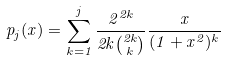<formula> <loc_0><loc_0><loc_500><loc_500>p _ { j } ( x ) = \sum _ { k = 1 } ^ { j } \frac { 2 ^ { 2 k } } { 2 k \binom { 2 k } { k } } \frac { x } { ( 1 + x ^ { 2 } ) ^ { k } }</formula> 